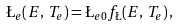Convert formula to latex. <formula><loc_0><loc_0><loc_500><loc_500>\L _ { e } ( E , \, T _ { e } ) = \L _ { e 0 } f _ { \L } ( E , \, T _ { e } ) \, ,</formula> 